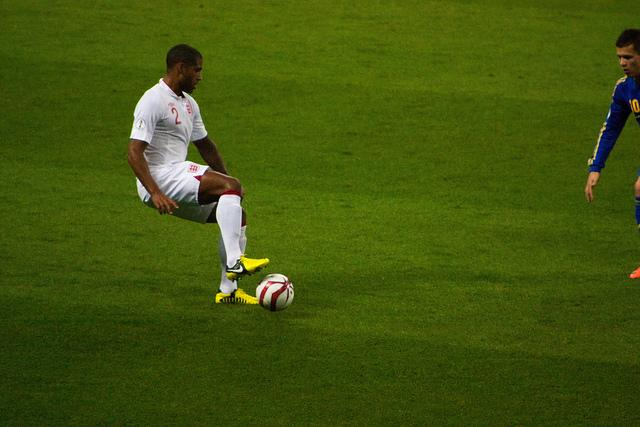The man with the ball has shoes that have a majority color that matches the color of what? Please explain your reasoning. mallard's bill. The shows look just like a bird's beak. 